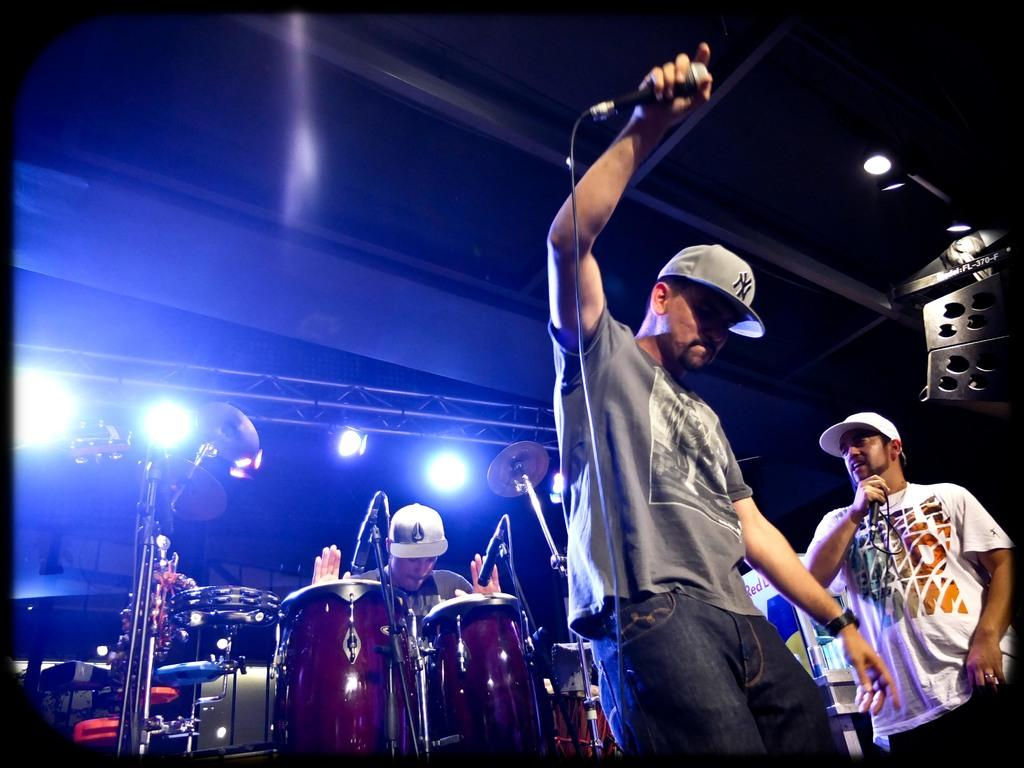What is the main subject of the image? The main subject of the image is a group of men. Where are the men located in the image? The men are standing on a stage in the image. What are the men holding in the image? The men are holding microphones in the image. What activity are the men engaged in? The men are playing drums in the image. What type of flock can be seen flying over the men in the image? There is no flock of birds visible in the image. What religious beliefs do the men in the image follow? There is no information about the men's religious beliefs in the image. 